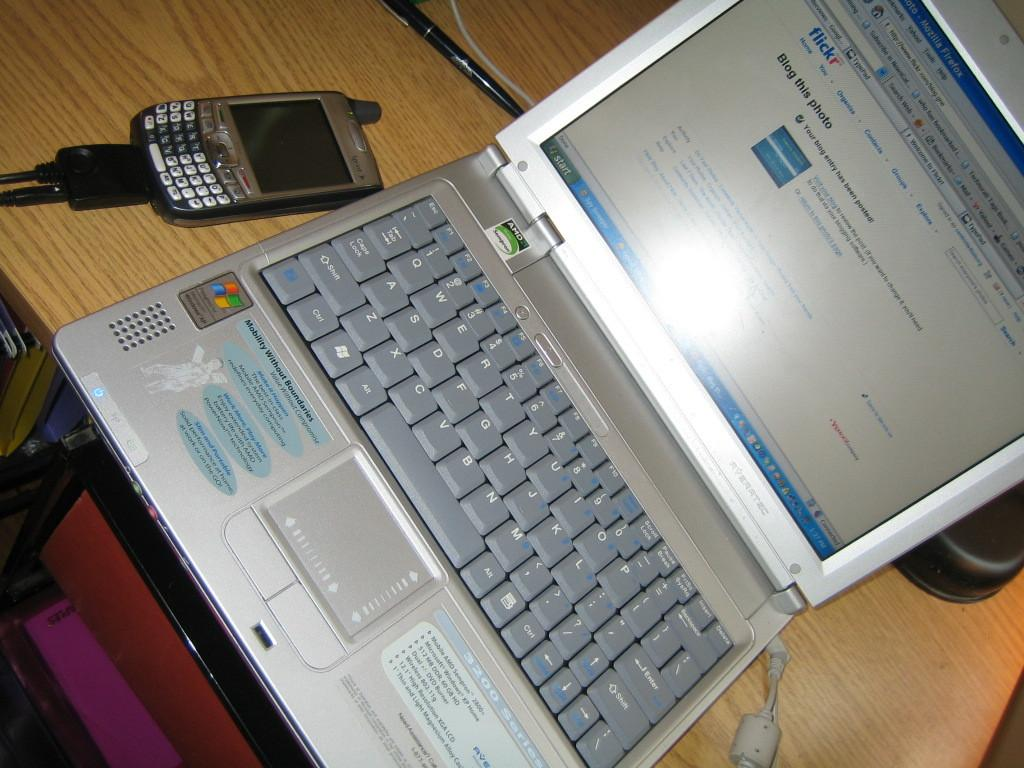<image>
Write a terse but informative summary of the picture. Blog this Photo on Flickr gives website visitors a way to bring energy to the image sharing site. 